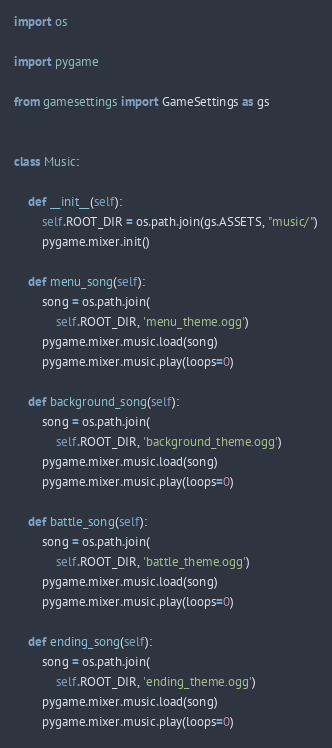Convert code to text. <code><loc_0><loc_0><loc_500><loc_500><_Python_>import os

import pygame

from gamesettings import GameSettings as gs


class Music:

    def __init__(self):
        self.ROOT_DIR = os.path.join(gs.ASSETS, "music/")
        pygame.mixer.init()

    def menu_song(self):
        song = os.path.join(
            self.ROOT_DIR, 'menu_theme.ogg')
        pygame.mixer.music.load(song)
        pygame.mixer.music.play(loops=0)

    def background_song(self):
        song = os.path.join(
            self.ROOT_DIR, 'background_theme.ogg')
        pygame.mixer.music.load(song)
        pygame.mixer.music.play(loops=0)

    def battle_song(self):
        song = os.path.join(
            self.ROOT_DIR, 'battle_theme.ogg')
        pygame.mixer.music.load(song)
        pygame.mixer.music.play(loops=0)

    def ending_song(self):
        song = os.path.join(
            self.ROOT_DIR, 'ending_theme.ogg')
        pygame.mixer.music.load(song)
        pygame.mixer.music.play(loops=0)
</code> 